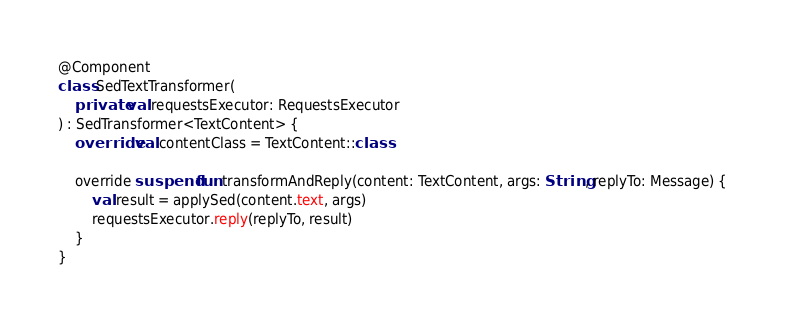<code> <loc_0><loc_0><loc_500><loc_500><_Kotlin_>
@Component
class SedTextTransformer(
    private val requestsExecutor: RequestsExecutor
) : SedTransformer<TextContent> {
    override val contentClass = TextContent::class

    override suspend fun transformAndReply(content: TextContent, args: String, replyTo: Message) {
        val result = applySed(content.text, args)
        requestsExecutor.reply(replyTo, result)
    }
}
</code> 